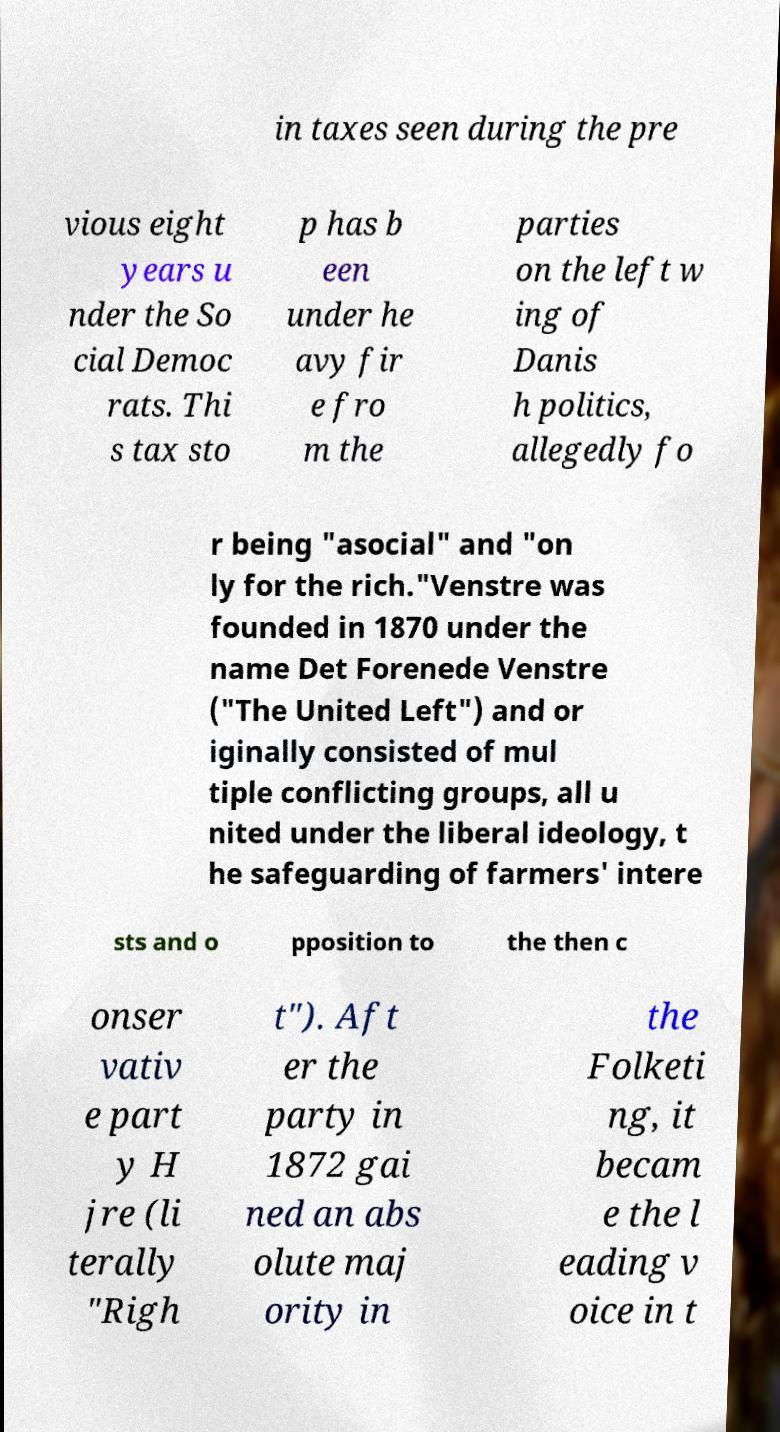Please identify and transcribe the text found in this image. in taxes seen during the pre vious eight years u nder the So cial Democ rats. Thi s tax sto p has b een under he avy fir e fro m the parties on the left w ing of Danis h politics, allegedly fo r being "asocial" and "on ly for the rich."Venstre was founded in 1870 under the name Det Forenede Venstre ("The United Left") and or iginally consisted of mul tiple conflicting groups, all u nited under the liberal ideology, t he safeguarding of farmers' intere sts and o pposition to the then c onser vativ e part y H jre (li terally "Righ t"). Aft er the party in 1872 gai ned an abs olute maj ority in the Folketi ng, it becam e the l eading v oice in t 